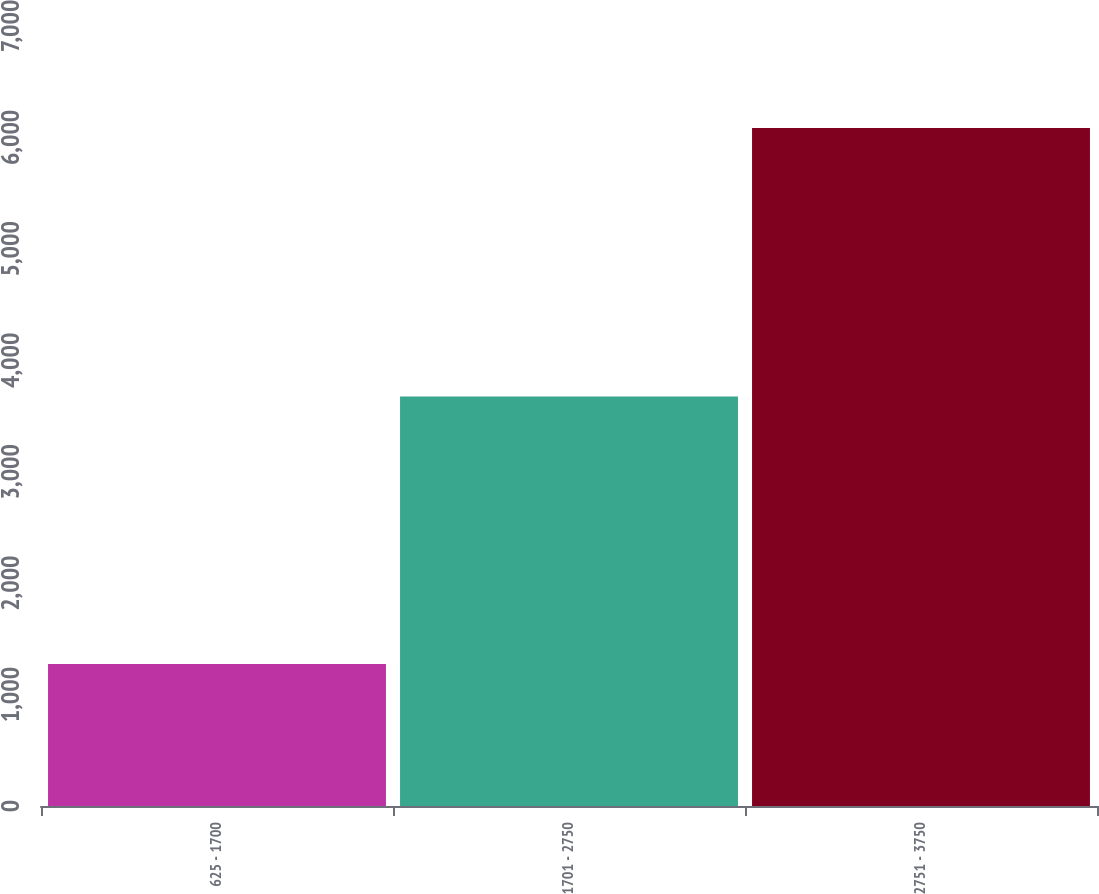Convert chart to OTSL. <chart><loc_0><loc_0><loc_500><loc_500><bar_chart><fcel>625 - 1700<fcel>1701 - 2750<fcel>2751 - 3750<nl><fcel>1275<fcel>3675<fcel>6085<nl></chart> 